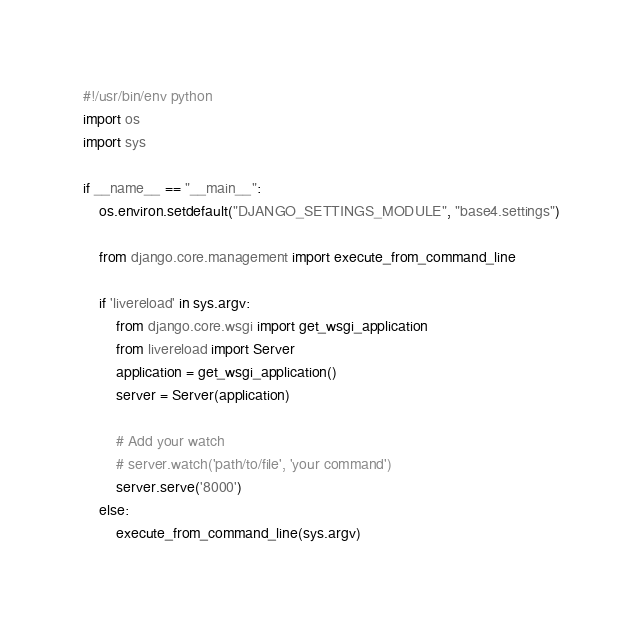<code> <loc_0><loc_0><loc_500><loc_500><_Python_>#!/usr/bin/env python
import os
import sys

if __name__ == "__main__":
    os.environ.setdefault("DJANGO_SETTINGS_MODULE", "base4.settings")

    from django.core.management import execute_from_command_line
    
    if 'livereload' in sys.argv:
        from django.core.wsgi import get_wsgi_application
        from livereload import Server
        application = get_wsgi_application()
        server = Server(application)

        # Add your watch
        # server.watch('path/to/file', 'your command')
        server.serve('8000')
    else:
        execute_from_command_line(sys.argv)

</code> 